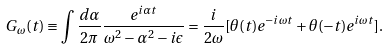Convert formula to latex. <formula><loc_0><loc_0><loc_500><loc_500>G _ { \omega } ( t ) \equiv \int \frac { d \alpha } { 2 \pi } \frac { e ^ { i \alpha t } } { \omega ^ { 2 } - \alpha ^ { 2 } - i \epsilon } = \frac { i } { 2 \omega } [ \theta ( t ) e ^ { - i \omega t } + \theta ( - t ) e ^ { i \omega t } ] .</formula> 